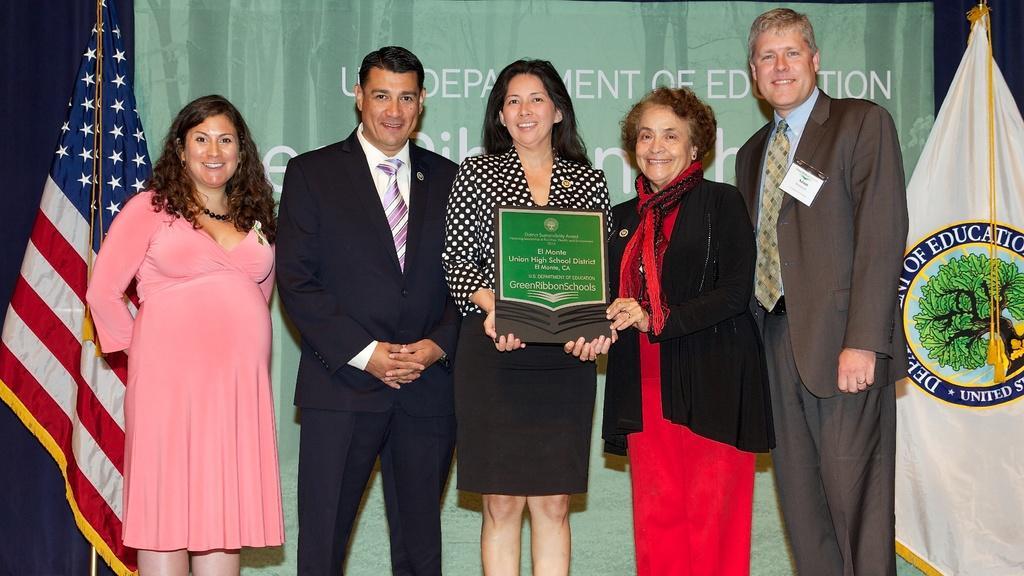Could you give a brief overview of what you see in this image? In this image I can see three women and two men standing and in the middle two women holding a board and in the background I can see the green color fence and I can see the flags on the right side and on the left side 